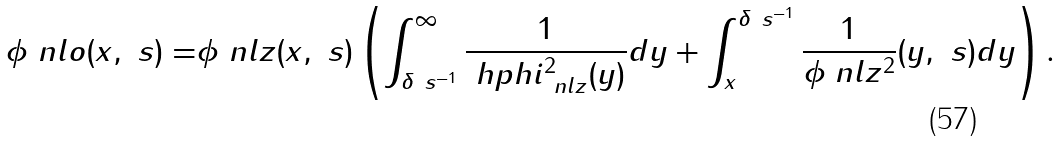<formula> <loc_0><loc_0><loc_500><loc_500>\phi _ { \ } n l o ( x , \ s ) = & \phi _ { \ } n l z ( x , \ s ) \left ( \int _ { \delta \ s ^ { - 1 } } ^ { \infty } \frac { 1 } { \ h p h i _ { \ n l z } ^ { 2 } ( y ) } d y + \int _ { x } ^ { \delta \ s ^ { - 1 } } \frac { 1 } { \phi _ { \ } n l z ^ { 2 } } ( y , \ s ) d y \right ) .</formula> 